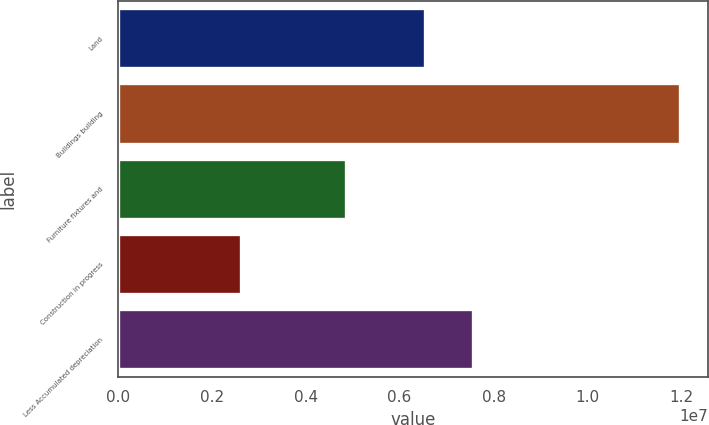Convert chart. <chart><loc_0><loc_0><loc_500><loc_500><bar_chart><fcel>Land<fcel>Buildings building<fcel>Furniture fixtures and<fcel>Construction in progress<fcel>Less Accumulated depreciation<nl><fcel>6.53099e+06<fcel>1.197e+07<fcel>4.86365e+06<fcel>2.6286e+06<fcel>7.5682e+06<nl></chart> 